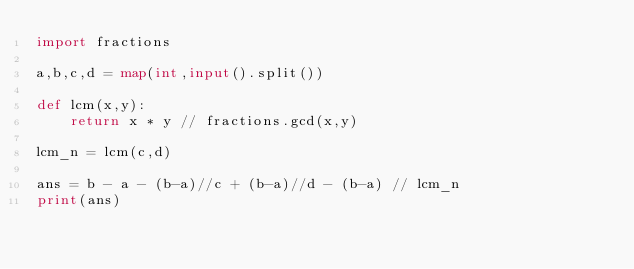Convert code to text. <code><loc_0><loc_0><loc_500><loc_500><_Python_>import fractions

a,b,c,d = map(int,input().split())

def lcm(x,y):
    return x * y // fractions.gcd(x,y)

lcm_n = lcm(c,d)

ans = b - a - (b-a)//c + (b-a)//d - (b-a) // lcm_n
print(ans)</code> 